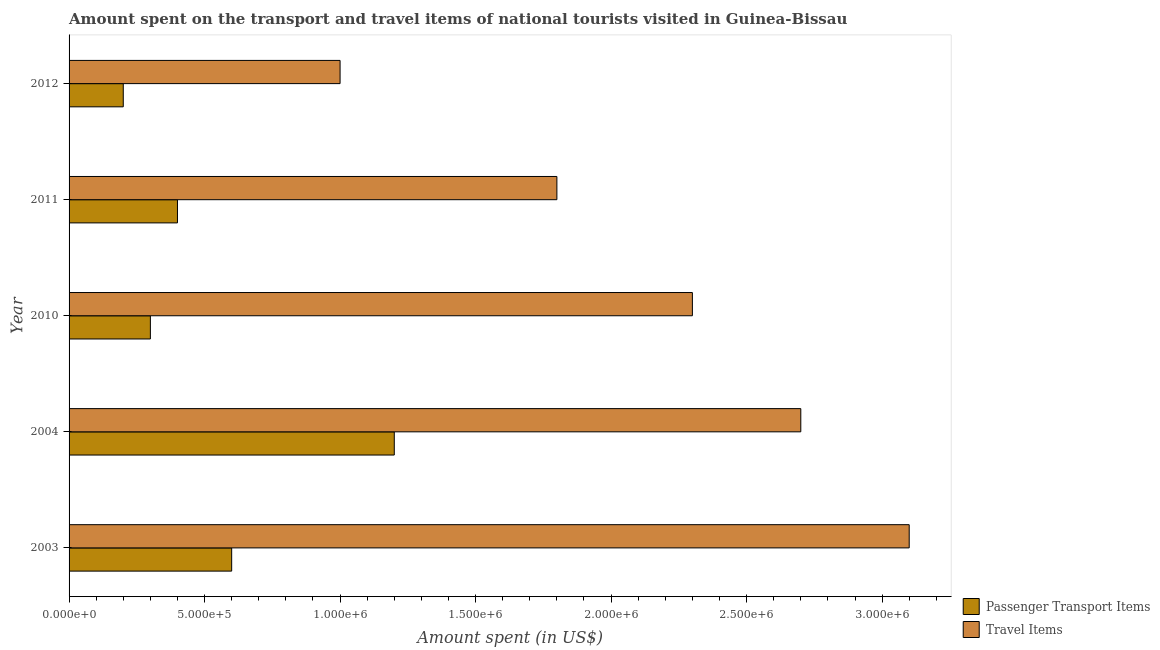How many different coloured bars are there?
Offer a terse response. 2. Are the number of bars per tick equal to the number of legend labels?
Your answer should be compact. Yes. Are the number of bars on each tick of the Y-axis equal?
Your response must be concise. Yes. How many bars are there on the 1st tick from the top?
Offer a terse response. 2. How many bars are there on the 4th tick from the bottom?
Make the answer very short. 2. What is the label of the 1st group of bars from the top?
Provide a short and direct response. 2012. What is the amount spent in travel items in 2011?
Your answer should be compact. 1.80e+06. Across all years, what is the maximum amount spent in travel items?
Offer a very short reply. 3.10e+06. Across all years, what is the minimum amount spent on passenger transport items?
Provide a short and direct response. 2.00e+05. What is the total amount spent on passenger transport items in the graph?
Your response must be concise. 2.70e+06. What is the difference between the amount spent in travel items in 2003 and that in 2012?
Make the answer very short. 2.10e+06. What is the difference between the amount spent in travel items in 2012 and the amount spent on passenger transport items in 2010?
Make the answer very short. 7.00e+05. What is the average amount spent on passenger transport items per year?
Ensure brevity in your answer.  5.40e+05. In the year 2011, what is the difference between the amount spent in travel items and amount spent on passenger transport items?
Provide a succinct answer. 1.40e+06. In how many years, is the amount spent in travel items greater than 300000 US$?
Keep it short and to the point. 5. Is the amount spent in travel items in 2003 less than that in 2011?
Offer a terse response. No. Is the difference between the amount spent on passenger transport items in 2003 and 2010 greater than the difference between the amount spent in travel items in 2003 and 2010?
Your response must be concise. No. What is the difference between the highest and the lowest amount spent in travel items?
Provide a short and direct response. 2.10e+06. In how many years, is the amount spent in travel items greater than the average amount spent in travel items taken over all years?
Your answer should be very brief. 3. Is the sum of the amount spent in travel items in 2004 and 2011 greater than the maximum amount spent on passenger transport items across all years?
Ensure brevity in your answer.  Yes. What does the 2nd bar from the top in 2010 represents?
Ensure brevity in your answer.  Passenger Transport Items. What does the 2nd bar from the bottom in 2011 represents?
Provide a succinct answer. Travel Items. How many bars are there?
Make the answer very short. 10. Are all the bars in the graph horizontal?
Ensure brevity in your answer.  Yes. Are the values on the major ticks of X-axis written in scientific E-notation?
Provide a succinct answer. Yes. Does the graph contain grids?
Provide a short and direct response. No. Where does the legend appear in the graph?
Provide a short and direct response. Bottom right. How many legend labels are there?
Provide a short and direct response. 2. What is the title of the graph?
Give a very brief answer. Amount spent on the transport and travel items of national tourists visited in Guinea-Bissau. Does "Forest" appear as one of the legend labels in the graph?
Offer a terse response. No. What is the label or title of the X-axis?
Ensure brevity in your answer.  Amount spent (in US$). What is the label or title of the Y-axis?
Offer a very short reply. Year. What is the Amount spent (in US$) in Travel Items in 2003?
Provide a short and direct response. 3.10e+06. What is the Amount spent (in US$) of Passenger Transport Items in 2004?
Provide a succinct answer. 1.20e+06. What is the Amount spent (in US$) in Travel Items in 2004?
Ensure brevity in your answer.  2.70e+06. What is the Amount spent (in US$) in Travel Items in 2010?
Keep it short and to the point. 2.30e+06. What is the Amount spent (in US$) of Travel Items in 2011?
Offer a terse response. 1.80e+06. Across all years, what is the maximum Amount spent (in US$) in Passenger Transport Items?
Your response must be concise. 1.20e+06. Across all years, what is the maximum Amount spent (in US$) in Travel Items?
Ensure brevity in your answer.  3.10e+06. What is the total Amount spent (in US$) in Passenger Transport Items in the graph?
Provide a succinct answer. 2.70e+06. What is the total Amount spent (in US$) of Travel Items in the graph?
Offer a very short reply. 1.09e+07. What is the difference between the Amount spent (in US$) in Passenger Transport Items in 2003 and that in 2004?
Provide a short and direct response. -6.00e+05. What is the difference between the Amount spent (in US$) of Travel Items in 2003 and that in 2004?
Keep it short and to the point. 4.00e+05. What is the difference between the Amount spent (in US$) in Passenger Transport Items in 2003 and that in 2010?
Your response must be concise. 3.00e+05. What is the difference between the Amount spent (in US$) in Travel Items in 2003 and that in 2010?
Offer a terse response. 8.00e+05. What is the difference between the Amount spent (in US$) in Passenger Transport Items in 2003 and that in 2011?
Offer a terse response. 2.00e+05. What is the difference between the Amount spent (in US$) of Travel Items in 2003 and that in 2011?
Offer a terse response. 1.30e+06. What is the difference between the Amount spent (in US$) in Travel Items in 2003 and that in 2012?
Offer a terse response. 2.10e+06. What is the difference between the Amount spent (in US$) in Passenger Transport Items in 2004 and that in 2010?
Your answer should be compact. 9.00e+05. What is the difference between the Amount spent (in US$) of Travel Items in 2004 and that in 2010?
Your response must be concise. 4.00e+05. What is the difference between the Amount spent (in US$) of Passenger Transport Items in 2004 and that in 2012?
Make the answer very short. 1.00e+06. What is the difference between the Amount spent (in US$) in Travel Items in 2004 and that in 2012?
Provide a succinct answer. 1.70e+06. What is the difference between the Amount spent (in US$) in Travel Items in 2010 and that in 2011?
Ensure brevity in your answer.  5.00e+05. What is the difference between the Amount spent (in US$) in Travel Items in 2010 and that in 2012?
Offer a terse response. 1.30e+06. What is the difference between the Amount spent (in US$) of Passenger Transport Items in 2011 and that in 2012?
Keep it short and to the point. 2.00e+05. What is the difference between the Amount spent (in US$) in Passenger Transport Items in 2003 and the Amount spent (in US$) in Travel Items in 2004?
Offer a very short reply. -2.10e+06. What is the difference between the Amount spent (in US$) in Passenger Transport Items in 2003 and the Amount spent (in US$) in Travel Items in 2010?
Ensure brevity in your answer.  -1.70e+06. What is the difference between the Amount spent (in US$) in Passenger Transport Items in 2003 and the Amount spent (in US$) in Travel Items in 2011?
Ensure brevity in your answer.  -1.20e+06. What is the difference between the Amount spent (in US$) in Passenger Transport Items in 2003 and the Amount spent (in US$) in Travel Items in 2012?
Your answer should be very brief. -4.00e+05. What is the difference between the Amount spent (in US$) of Passenger Transport Items in 2004 and the Amount spent (in US$) of Travel Items in 2010?
Your answer should be very brief. -1.10e+06. What is the difference between the Amount spent (in US$) in Passenger Transport Items in 2004 and the Amount spent (in US$) in Travel Items in 2011?
Provide a short and direct response. -6.00e+05. What is the difference between the Amount spent (in US$) of Passenger Transport Items in 2004 and the Amount spent (in US$) of Travel Items in 2012?
Your answer should be compact. 2.00e+05. What is the difference between the Amount spent (in US$) in Passenger Transport Items in 2010 and the Amount spent (in US$) in Travel Items in 2011?
Offer a terse response. -1.50e+06. What is the difference between the Amount spent (in US$) in Passenger Transport Items in 2010 and the Amount spent (in US$) in Travel Items in 2012?
Keep it short and to the point. -7.00e+05. What is the difference between the Amount spent (in US$) in Passenger Transport Items in 2011 and the Amount spent (in US$) in Travel Items in 2012?
Provide a short and direct response. -6.00e+05. What is the average Amount spent (in US$) in Passenger Transport Items per year?
Your response must be concise. 5.40e+05. What is the average Amount spent (in US$) of Travel Items per year?
Your response must be concise. 2.18e+06. In the year 2003, what is the difference between the Amount spent (in US$) of Passenger Transport Items and Amount spent (in US$) of Travel Items?
Make the answer very short. -2.50e+06. In the year 2004, what is the difference between the Amount spent (in US$) of Passenger Transport Items and Amount spent (in US$) of Travel Items?
Ensure brevity in your answer.  -1.50e+06. In the year 2010, what is the difference between the Amount spent (in US$) of Passenger Transport Items and Amount spent (in US$) of Travel Items?
Keep it short and to the point. -2.00e+06. In the year 2011, what is the difference between the Amount spent (in US$) in Passenger Transport Items and Amount spent (in US$) in Travel Items?
Your response must be concise. -1.40e+06. In the year 2012, what is the difference between the Amount spent (in US$) of Passenger Transport Items and Amount spent (in US$) of Travel Items?
Offer a terse response. -8.00e+05. What is the ratio of the Amount spent (in US$) in Travel Items in 2003 to that in 2004?
Keep it short and to the point. 1.15. What is the ratio of the Amount spent (in US$) of Travel Items in 2003 to that in 2010?
Give a very brief answer. 1.35. What is the ratio of the Amount spent (in US$) in Travel Items in 2003 to that in 2011?
Give a very brief answer. 1.72. What is the ratio of the Amount spent (in US$) of Passenger Transport Items in 2003 to that in 2012?
Keep it short and to the point. 3. What is the ratio of the Amount spent (in US$) of Travel Items in 2004 to that in 2010?
Give a very brief answer. 1.17. What is the ratio of the Amount spent (in US$) of Passenger Transport Items in 2004 to that in 2011?
Your answer should be very brief. 3. What is the ratio of the Amount spent (in US$) in Passenger Transport Items in 2010 to that in 2011?
Provide a succinct answer. 0.75. What is the ratio of the Amount spent (in US$) in Travel Items in 2010 to that in 2011?
Your answer should be compact. 1.28. What is the ratio of the Amount spent (in US$) of Travel Items in 2010 to that in 2012?
Provide a short and direct response. 2.3. What is the ratio of the Amount spent (in US$) of Passenger Transport Items in 2011 to that in 2012?
Your answer should be compact. 2. What is the ratio of the Amount spent (in US$) in Travel Items in 2011 to that in 2012?
Make the answer very short. 1.8. What is the difference between the highest and the second highest Amount spent (in US$) in Passenger Transport Items?
Your response must be concise. 6.00e+05. What is the difference between the highest and the second highest Amount spent (in US$) in Travel Items?
Offer a very short reply. 4.00e+05. What is the difference between the highest and the lowest Amount spent (in US$) of Travel Items?
Provide a succinct answer. 2.10e+06. 